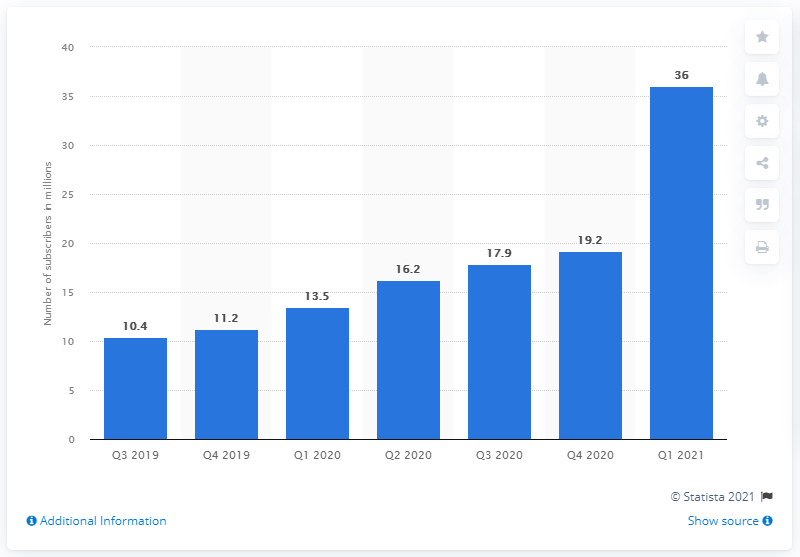Indicate a few pertinent items in this graphic. In the first quarter of 2021, there were a total of 36 ViacomCBS subscribers. 